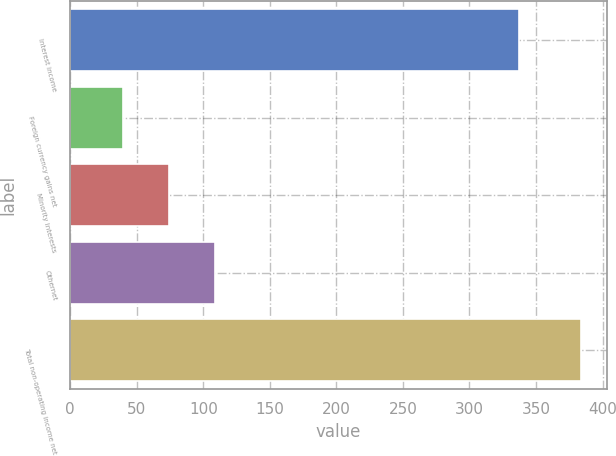Convert chart. <chart><loc_0><loc_0><loc_500><loc_500><bar_chart><fcel>Interest income<fcel>Foreign currency gains net<fcel>Minority interests<fcel>Othernet<fcel>Total non-operating income net<nl><fcel>337<fcel>40<fcel>74.4<fcel>108.8<fcel>384<nl></chart> 